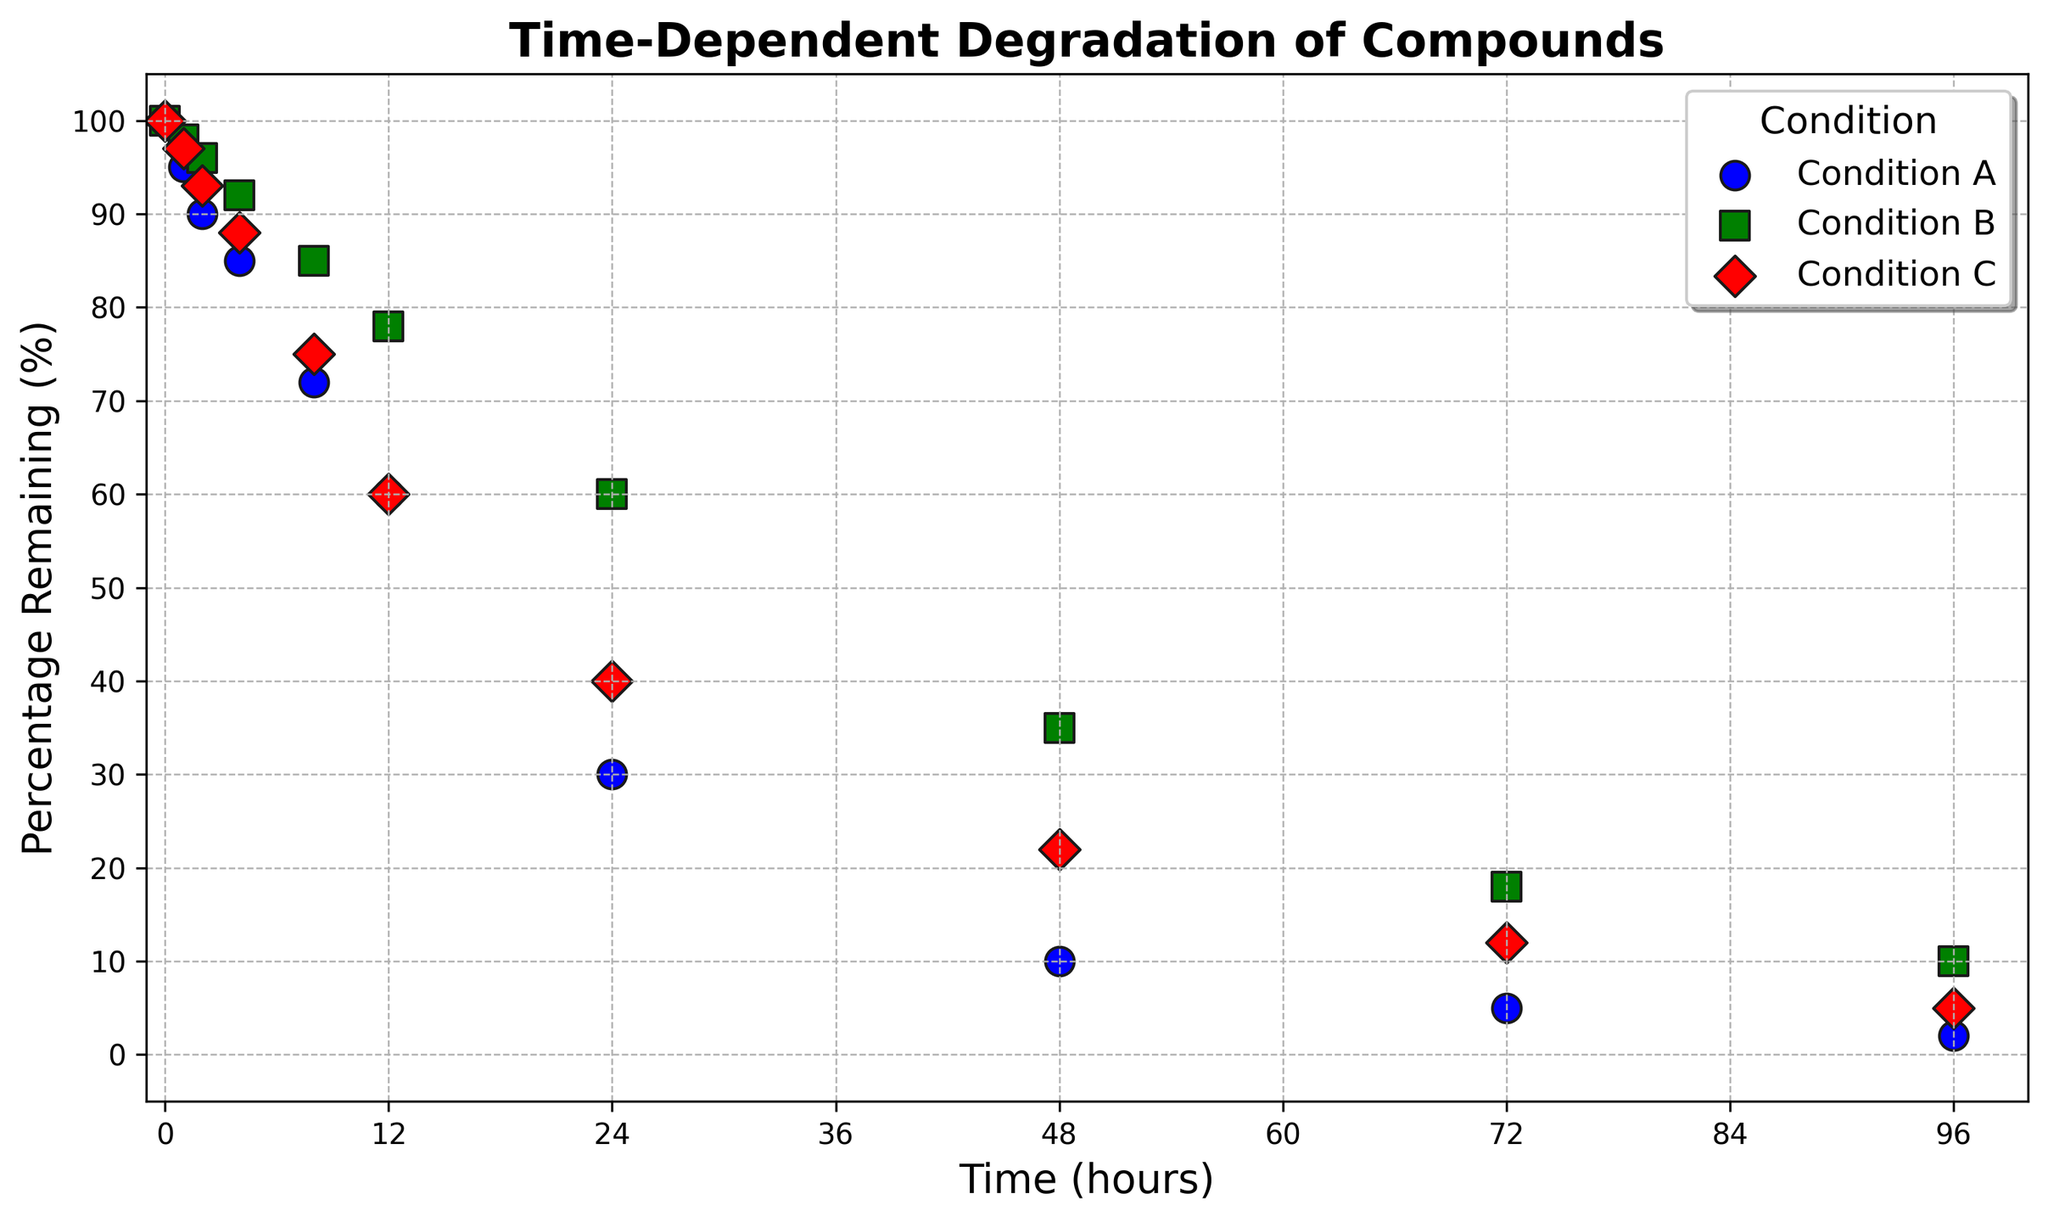What is the percentage of the compound remaining in Condition A after 12 hours? From the plot, locate the data point for Condition A at the 12-hour mark on the x-axis. The corresponding y-axis value shows the percentage remaining.
Answer: 60% Which condition shows the highest percentage remaining after 48 hours? Check the data points for all three conditions at the 48-hour mark on the x-axis. Compare the y-axis values to determine which one is the highest.
Answer: Condition B At what time do Conditions A and C have the same percentage of compound remaining? Identify the points where the curves for Conditions A and C intersect. Use the x-axis value of this intersection point.
Answer: 12 hours How many hours does it take for Condition B to degrade to 50%? From the curve representing Condition B, find the interval point on the x-axis where the y-axis value is 50%. This matches the percentage remaining at that time.
Answer: Between 12 and 24 hours If you take the average percentage remaining at 24 hours across all conditions, what do you get? Find the y-values for all conditions at the 24-hour mark (Condition A: 30%, Condition B: 60%, Condition C: 40%). Compute the average of these values: (30 + 60 + 40) / 3 = 43.33%.
Answer: 43.33% Which condition has the steepest decrease in percentage remaining from 0 to 24 hours? Determine the slope (rate of change) of the curves between 0 and 24 hours by visually estimating the decline in y-values. The steeper the slope, the faster the decrease.
Answer: Condition A What is the difference in the percentage remaining between Conditions B and C after 12 hours? Find the percentage remaining for Conditions B and C at the 12-hour mark and calculate the difference: 78% (B) - 60% (C) = 18%.
Answer: 18% What is the visual marker used for Condition B in the plot? Look at the legend that indicates the marker style for each condition.
Answer: Square (s) After how many hours does Condition A fall below 10% remaining? Check the curve for Condition A and locate the x-axis value where the y-value drops below 10%.
Answer: After 48 hours If you combine the percentages remaining for all conditions at the 4-hour mark, what total do you get? Add the y-values at 4 hours for Conditions A, B, and C: 85% (A) + 92% (B) + 88% (C) = 265%.
Answer: 265% 